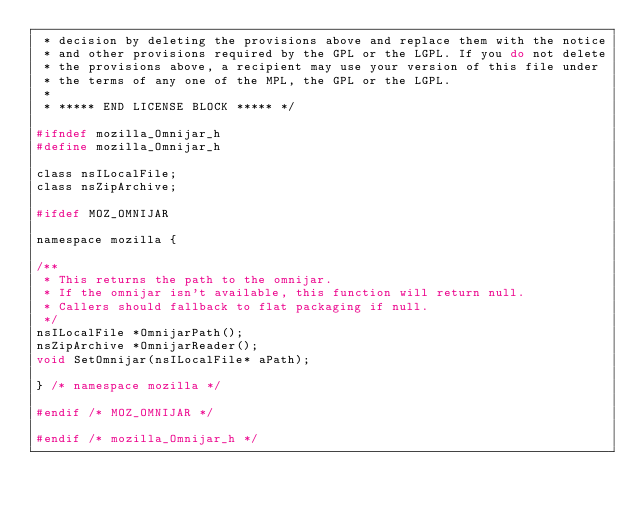<code> <loc_0><loc_0><loc_500><loc_500><_C_> * decision by deleting the provisions above and replace them with the notice
 * and other provisions required by the GPL or the LGPL. If you do not delete
 * the provisions above, a recipient may use your version of this file under
 * the terms of any one of the MPL, the GPL or the LGPL.
 *
 * ***** END LICENSE BLOCK ***** */

#ifndef mozilla_Omnijar_h
#define mozilla_Omnijar_h

class nsILocalFile;
class nsZipArchive;

#ifdef MOZ_OMNIJAR

namespace mozilla {

/**
 * This returns the path to the omnijar.
 * If the omnijar isn't available, this function will return null.
 * Callers should fallback to flat packaging if null.
 */
nsILocalFile *OmnijarPath();
nsZipArchive *OmnijarReader();
void SetOmnijar(nsILocalFile* aPath);

} /* namespace mozilla */

#endif /* MOZ_OMNIJAR */

#endif /* mozilla_Omnijar_h */
</code> 